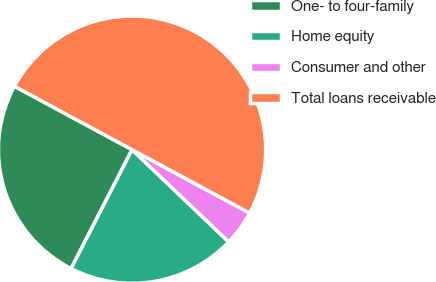Convert chart to OTSL. <chart><loc_0><loc_0><loc_500><loc_500><pie_chart><fcel>One- to four-family<fcel>Home equity<fcel>Consumer and other<fcel>Total loans receivable<nl><fcel>25.33%<fcel>20.41%<fcel>4.26%<fcel>50.0%<nl></chart> 